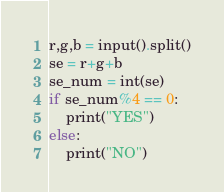Convert code to text. <code><loc_0><loc_0><loc_500><loc_500><_Python_>r,g,b = input().split()
se = r+g+b
se_num = int(se)
if se_num%4 == 0:
    print("YES")
else:
    print("NO")</code> 